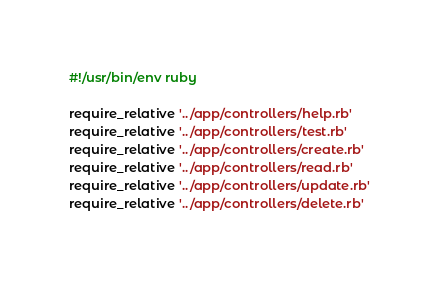Convert code to text. <code><loc_0><loc_0><loc_500><loc_500><_Ruby_>#!/usr/bin/env ruby

require_relative '../app/controllers/help.rb'
require_relative '../app/controllers/test.rb'
require_relative '../app/controllers/create.rb'
require_relative '../app/controllers/read.rb'
require_relative '../app/controllers/update.rb'
require_relative '../app/controllers/delete.rb'</code> 